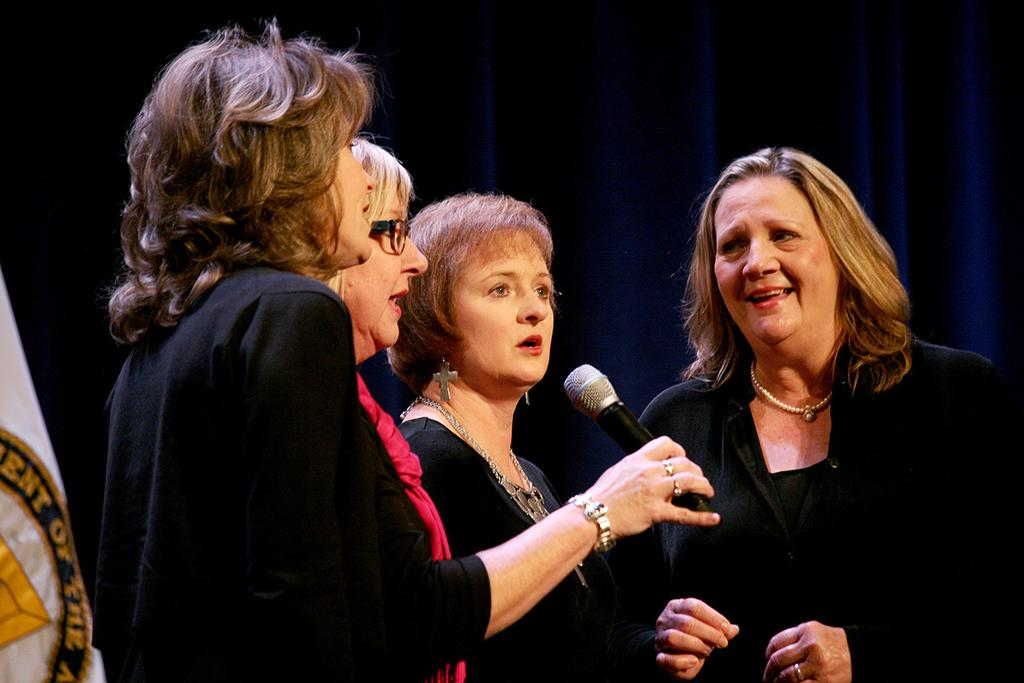What is the woman wearing in the image? The woman is wearing pink in the image. What is the woman doing in the image? The woman is standing and holding a microphone in her hand. How many other people are in the image? There are three other people in the image. What are the other people doing in the image? The other people are singing with the woman. What type of tooth can be seen in the image? There is no tooth present in the image. What view can be seen from the location of the image? The provided facts do not give any information about the location or the view from the location, so it cannot be determined. 